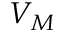<formula> <loc_0><loc_0><loc_500><loc_500>V _ { M }</formula> 